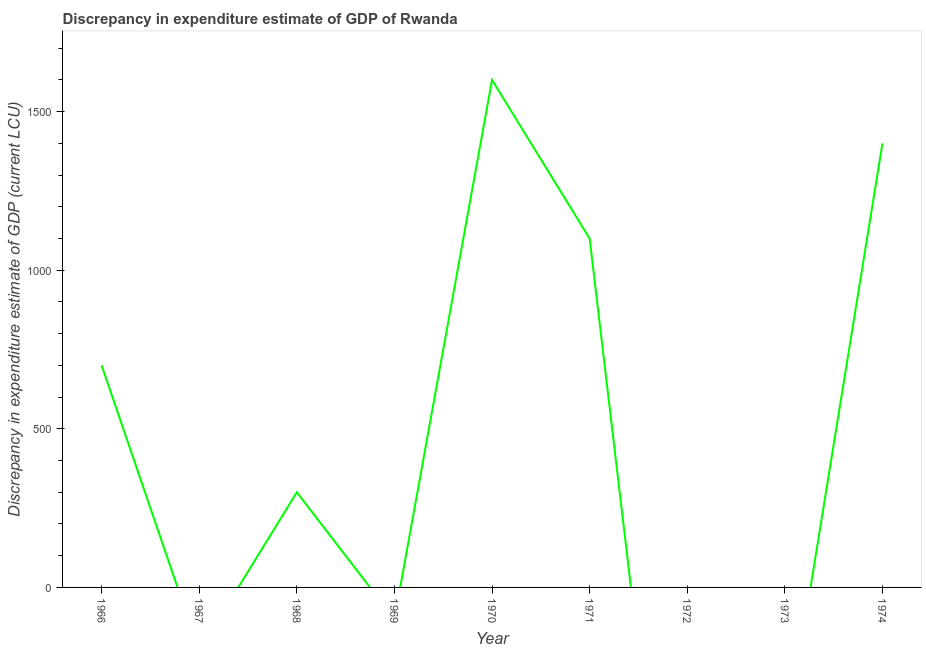Across all years, what is the maximum discrepancy in expenditure estimate of gdp?
Make the answer very short. 1600. Across all years, what is the minimum discrepancy in expenditure estimate of gdp?
Provide a succinct answer. 0. In which year was the discrepancy in expenditure estimate of gdp maximum?
Keep it short and to the point. 1970. What is the sum of the discrepancy in expenditure estimate of gdp?
Ensure brevity in your answer.  5100. What is the difference between the discrepancy in expenditure estimate of gdp in 1966 and 1968?
Make the answer very short. 400. What is the average discrepancy in expenditure estimate of gdp per year?
Give a very brief answer. 566.67. What is the median discrepancy in expenditure estimate of gdp?
Your response must be concise. 300. In how many years, is the discrepancy in expenditure estimate of gdp greater than 1400 LCU?
Offer a very short reply. 1. What is the ratio of the discrepancy in expenditure estimate of gdp in 1968 to that in 1974?
Provide a succinct answer. 0.21. Is the difference between the discrepancy in expenditure estimate of gdp in 1966 and 1970 greater than the difference between any two years?
Your response must be concise. No. What is the difference between the highest and the second highest discrepancy in expenditure estimate of gdp?
Make the answer very short. 200. Is the sum of the discrepancy in expenditure estimate of gdp in 1968 and 1970 greater than the maximum discrepancy in expenditure estimate of gdp across all years?
Provide a short and direct response. Yes. What is the difference between the highest and the lowest discrepancy in expenditure estimate of gdp?
Your answer should be compact. 1600. In how many years, is the discrepancy in expenditure estimate of gdp greater than the average discrepancy in expenditure estimate of gdp taken over all years?
Make the answer very short. 4. Does the discrepancy in expenditure estimate of gdp monotonically increase over the years?
Your answer should be compact. No. How many lines are there?
Provide a short and direct response. 1. How many years are there in the graph?
Your answer should be very brief. 9. Does the graph contain any zero values?
Make the answer very short. Yes. What is the title of the graph?
Keep it short and to the point. Discrepancy in expenditure estimate of GDP of Rwanda. What is the label or title of the Y-axis?
Your answer should be compact. Discrepancy in expenditure estimate of GDP (current LCU). What is the Discrepancy in expenditure estimate of GDP (current LCU) in 1966?
Offer a terse response. 700. What is the Discrepancy in expenditure estimate of GDP (current LCU) of 1968?
Offer a terse response. 300. What is the Discrepancy in expenditure estimate of GDP (current LCU) in 1969?
Give a very brief answer. 0. What is the Discrepancy in expenditure estimate of GDP (current LCU) of 1970?
Offer a very short reply. 1600. What is the Discrepancy in expenditure estimate of GDP (current LCU) in 1971?
Offer a terse response. 1100. What is the Discrepancy in expenditure estimate of GDP (current LCU) in 1974?
Your answer should be very brief. 1400. What is the difference between the Discrepancy in expenditure estimate of GDP (current LCU) in 1966 and 1970?
Your answer should be compact. -900. What is the difference between the Discrepancy in expenditure estimate of GDP (current LCU) in 1966 and 1971?
Give a very brief answer. -400. What is the difference between the Discrepancy in expenditure estimate of GDP (current LCU) in 1966 and 1974?
Give a very brief answer. -700. What is the difference between the Discrepancy in expenditure estimate of GDP (current LCU) in 1968 and 1970?
Your answer should be compact. -1300. What is the difference between the Discrepancy in expenditure estimate of GDP (current LCU) in 1968 and 1971?
Keep it short and to the point. -800. What is the difference between the Discrepancy in expenditure estimate of GDP (current LCU) in 1968 and 1974?
Provide a succinct answer. -1100. What is the difference between the Discrepancy in expenditure estimate of GDP (current LCU) in 1970 and 1974?
Keep it short and to the point. 200. What is the difference between the Discrepancy in expenditure estimate of GDP (current LCU) in 1971 and 1974?
Keep it short and to the point. -300. What is the ratio of the Discrepancy in expenditure estimate of GDP (current LCU) in 1966 to that in 1968?
Make the answer very short. 2.33. What is the ratio of the Discrepancy in expenditure estimate of GDP (current LCU) in 1966 to that in 1970?
Offer a very short reply. 0.44. What is the ratio of the Discrepancy in expenditure estimate of GDP (current LCU) in 1966 to that in 1971?
Offer a very short reply. 0.64. What is the ratio of the Discrepancy in expenditure estimate of GDP (current LCU) in 1968 to that in 1970?
Keep it short and to the point. 0.19. What is the ratio of the Discrepancy in expenditure estimate of GDP (current LCU) in 1968 to that in 1971?
Give a very brief answer. 0.27. What is the ratio of the Discrepancy in expenditure estimate of GDP (current LCU) in 1968 to that in 1974?
Your answer should be very brief. 0.21. What is the ratio of the Discrepancy in expenditure estimate of GDP (current LCU) in 1970 to that in 1971?
Provide a succinct answer. 1.46. What is the ratio of the Discrepancy in expenditure estimate of GDP (current LCU) in 1970 to that in 1974?
Your response must be concise. 1.14. What is the ratio of the Discrepancy in expenditure estimate of GDP (current LCU) in 1971 to that in 1974?
Your response must be concise. 0.79. 